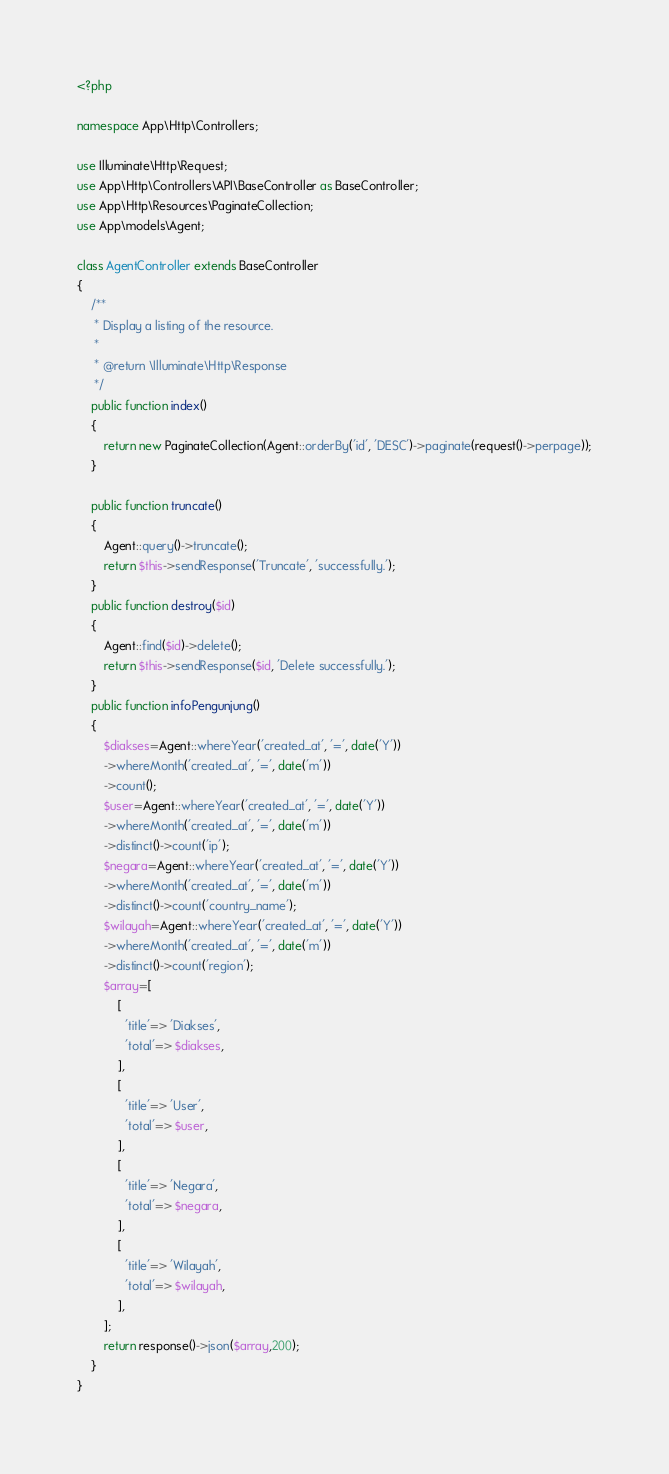Convert code to text. <code><loc_0><loc_0><loc_500><loc_500><_PHP_><?php

namespace App\Http\Controllers;

use Illuminate\Http\Request;
use App\Http\Controllers\API\BaseController as BaseController;
use App\Http\Resources\PaginateCollection;
use App\models\Agent;

class AgentController extends BaseController
{
    /**
     * Display a listing of the resource.
     *
     * @return \Illuminate\Http\Response
     */
    public function index()
    {
        return new PaginateCollection(Agent::orderBy('id', 'DESC')->paginate(request()->perpage));
    }

    public function truncate()
    {
        Agent::query()->truncate();
        return $this->sendResponse('Truncate', 'successfully.');
    }
    public function destroy($id)
    {
        Agent::find($id)->delete();
        return $this->sendResponse($id, 'Delete successfully.');
    }
    public function infoPengunjung()
    {
        $diakses=Agent::whereYear('created_at', '=', date('Y'))
        ->whereMonth('created_at', '=', date('m'))
        ->count();
        $user=Agent::whereYear('created_at', '=', date('Y'))
        ->whereMonth('created_at', '=', date('m'))
        ->distinct()->count('ip');
        $negara=Agent::whereYear('created_at', '=', date('Y'))
        ->whereMonth('created_at', '=', date('m'))
        ->distinct()->count('country_name');
        $wilayah=Agent::whereYear('created_at', '=', date('Y'))
        ->whereMonth('created_at', '=', date('m'))
        ->distinct()->count('region');
        $array=[
            [
              'title'=> 'Diakses',
              'total'=> $diakses,
            ],
            [
              'title'=> 'User',
              'total'=> $user,
            ],
            [
              'title'=> 'Negara',
              'total'=> $negara,
            ],
            [
              'title'=> 'Wilayah',
              'total'=> $wilayah,
            ],
        ];
        return response()->json($array,200);
    }
}
</code> 